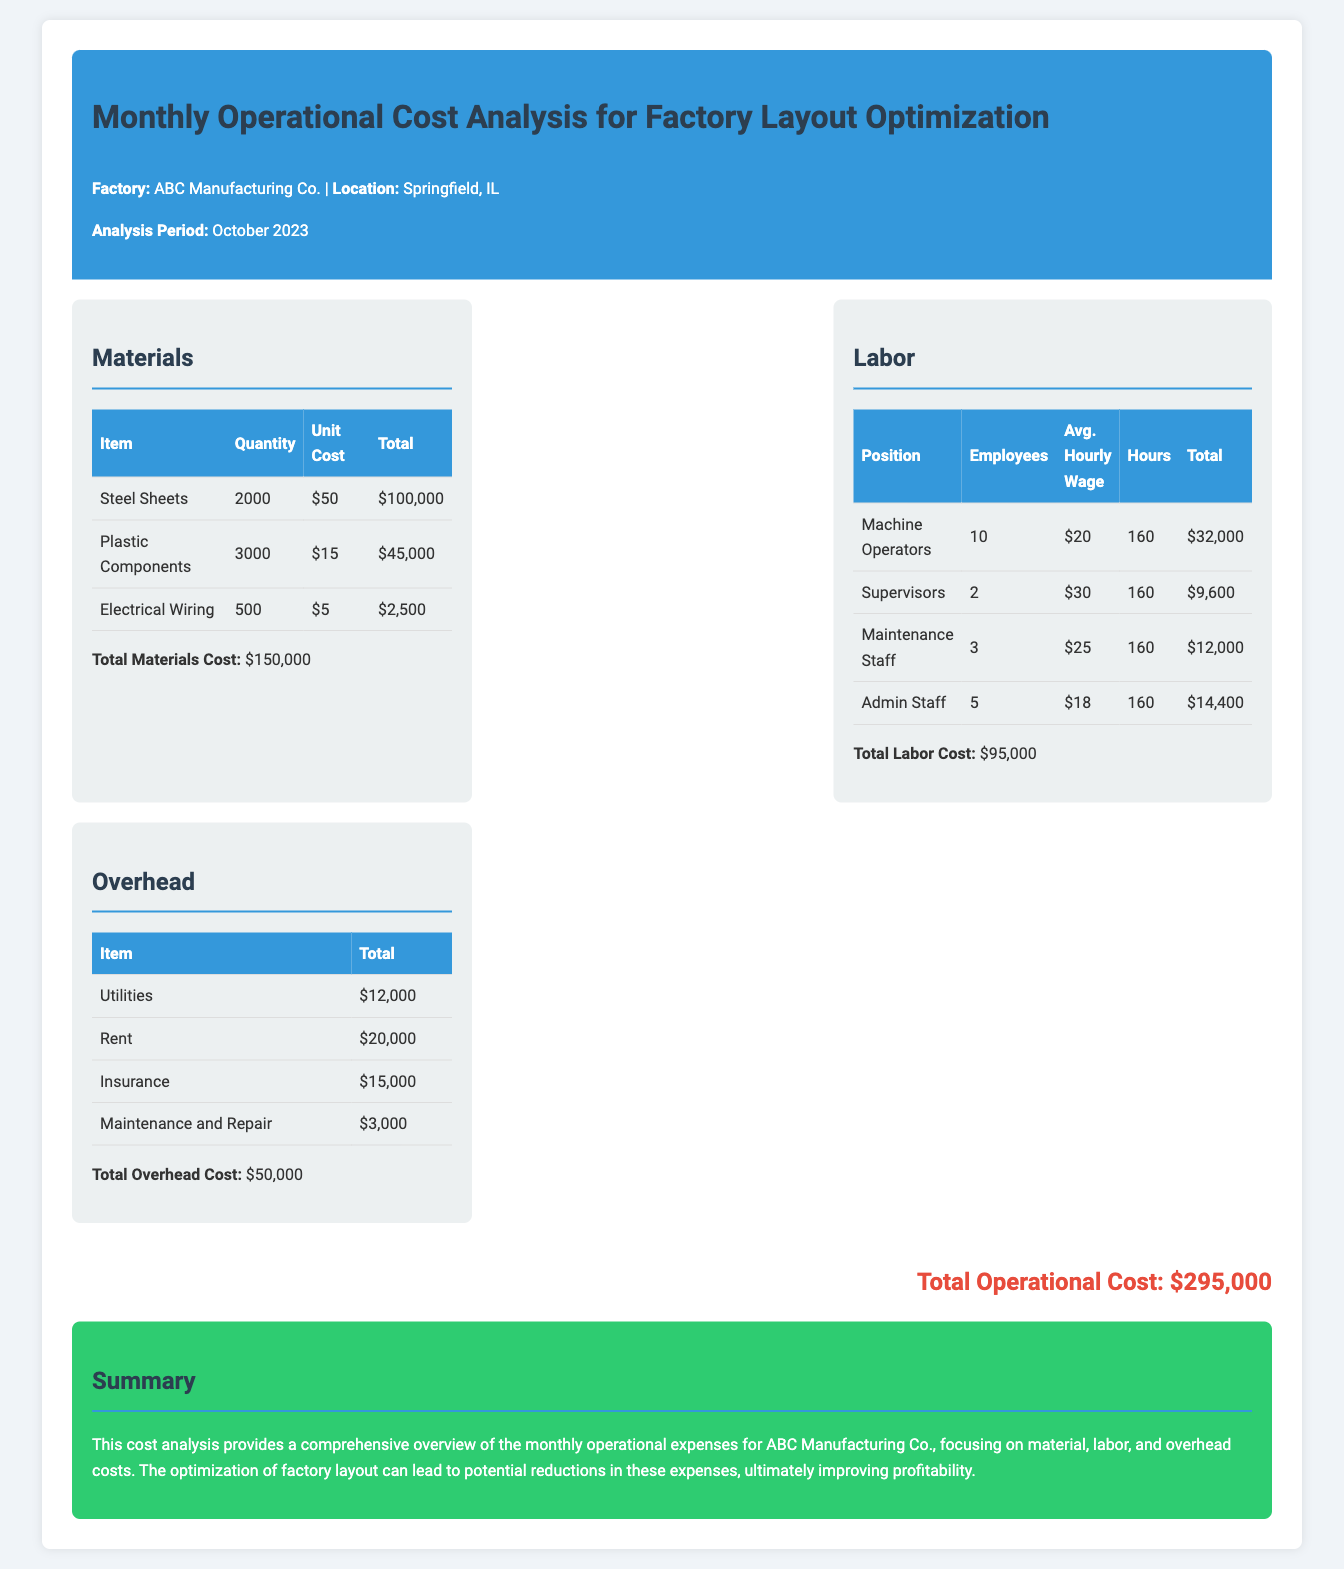What is the total materials cost? The total materials cost is provided in the document as the sum of all material expenses, which is $100,000 + $45,000 + $2,500.
Answer: $150,000 How many machine operators are there? The number of machine operators is specified in the labor section of the document as 10.
Answer: 10 What is the total labor cost? The total labor cost is calculated by summing all listed labor expenses, which is $32,000 + $9,600 + $12,000 + $14,400.
Answer: $95,000 What is the cost of rent? The document lists rent as one of the overhead items, with a specified amount of $20,000.
Answer: $20,000 What is the total operational cost? This is the combined total of materials, labor, and overhead costs, which is $150,000 + $95,000 + $50,000.
Answer: $295,000 How much is spent on utilities? The overhead section details utilities as an expense totaling $12,000.
Answer: $12,000 How many plastic components are purchased? The quantity of plastic components is listed in the materials section as 3,000.
Answer: 3,000 What is the average hourly wage of supervisors? The average hourly wage for supervisors is given as $30.
Answer: $30 What period does this operational cost analysis cover? The document specifies that the analysis period is October 2023.
Answer: October 2023 What is the total cost for maintenance and repair? The overhead section specifies the total cost for maintenance and repair as $3,000.
Answer: $3,000 